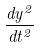<formula> <loc_0><loc_0><loc_500><loc_500>\frac { d y ^ { 2 } } { d t ^ { 2 } }</formula> 